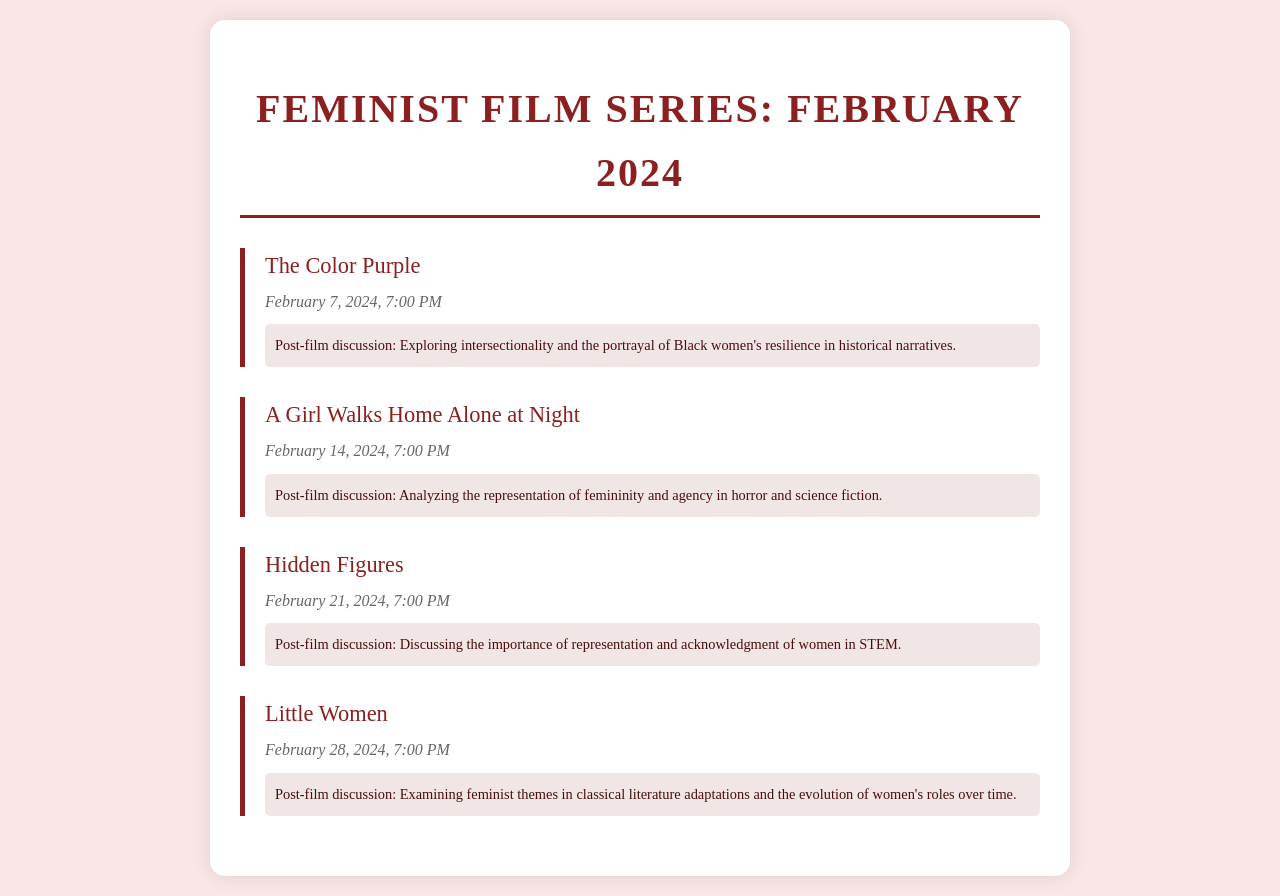What is the title of the film screened on February 7, 2024? The title of the film is explicitly listed in the document under the corresponding screening date.
Answer: The Color Purple What time does the film "A Girl Walks Home Alone at Night" start? The screening times are stated next to each film's title, allowing for direct retrieval of this information.
Answer: 7:00 PM What is the post-film discussion topic for "Hidden Figures"? Each film has a specified discussion topic provided within the document that correlates with the film's themes.
Answer: Discussing the importance of representation and acknowledgment of women in STEM Which film is scheduled for February 28, 2024? The schedule includes a list of films with their respective dates, making it easy to find the film for this date.
Answer: Little Women What overall theme is discussed following the screening of "The Color Purple"? The discussion topics often reflect deeper themes relevant to the film, which are outlined in the document.
Answer: Exploring intersectionality and the portrayal of Black women's resilience in historical narratives How many films are being screened in February 2024? The document lists the films, which can be counted for total films presented in that month.
Answer: Four What genre does "A Girl Walks Home Alone at Night" represent? This film's thematic representation is linked to the genre mentioned in the post-film discussion segment.
Answer: Horror and science fiction What recurring topic is examined in "Little Women"? The discussions associated with each film indicate the themes explored, hence this can be extracted for the film mentioned.
Answer: Examining feminist themes in classical literature adaptations and the evolution of women's roles over time What color is used for the background of the schedule document? The background color is set in the styling of the document and can be recognized visually.
Answer: #f9e6e6 